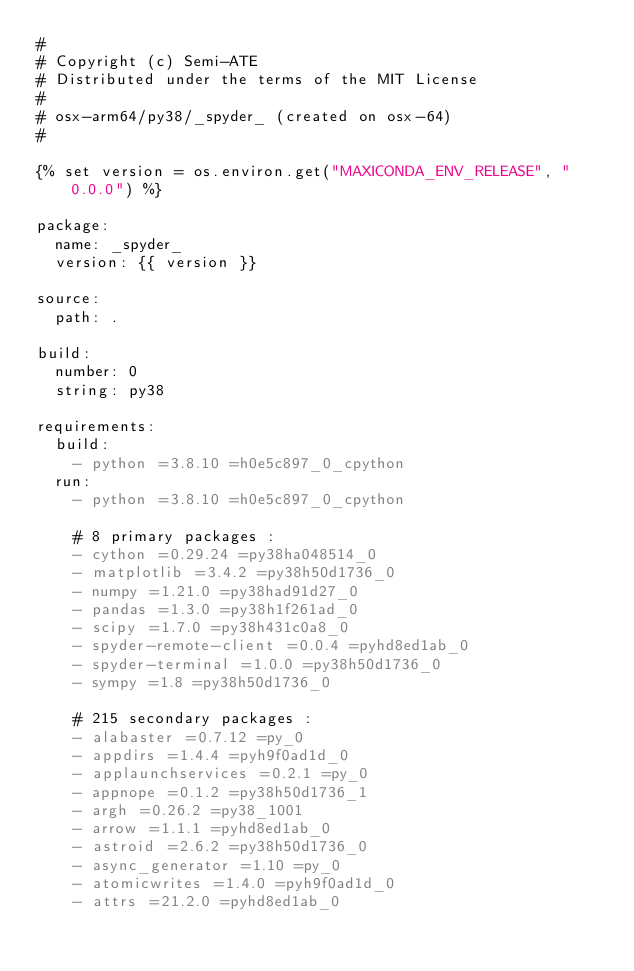<code> <loc_0><loc_0><loc_500><loc_500><_YAML_>#
# Copyright (c) Semi-ATE
# Distributed under the terms of the MIT License
#
# osx-arm64/py38/_spyder_ (created on osx-64)
#

{% set version = os.environ.get("MAXICONDA_ENV_RELEASE", "0.0.0") %}

package:
  name: _spyder_
  version: {{ version }}

source:
  path: .

build:
  number: 0
  string: py38

requirements:
  build:
    - python =3.8.10 =h0e5c897_0_cpython
  run:
    - python =3.8.10 =h0e5c897_0_cpython

    # 8 primary packages :
    - cython =0.29.24 =py38ha048514_0
    - matplotlib =3.4.2 =py38h50d1736_0
    - numpy =1.21.0 =py38had91d27_0
    - pandas =1.3.0 =py38h1f261ad_0
    - scipy =1.7.0 =py38h431c0a8_0
    - spyder-remote-client =0.0.4 =pyhd8ed1ab_0
    - spyder-terminal =1.0.0 =py38h50d1736_0
    - sympy =1.8 =py38h50d1736_0

    # 215 secondary packages :
    - alabaster =0.7.12 =py_0
    - appdirs =1.4.4 =pyh9f0ad1d_0
    - applaunchservices =0.2.1 =py_0
    - appnope =0.1.2 =py38h50d1736_1
    - argh =0.26.2 =py38_1001
    - arrow =1.1.1 =pyhd8ed1ab_0
    - astroid =2.6.2 =py38h50d1736_0
    - async_generator =1.10 =py_0
    - atomicwrites =1.4.0 =pyh9f0ad1d_0
    - attrs =21.2.0 =pyhd8ed1ab_0</code> 